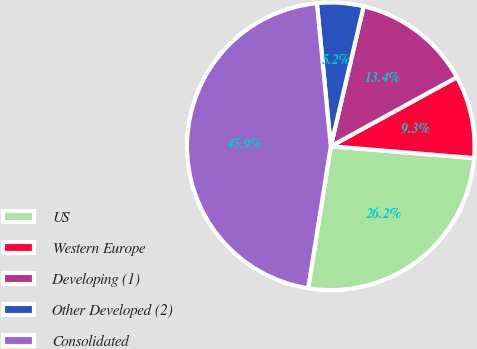Convert chart to OTSL. <chart><loc_0><loc_0><loc_500><loc_500><pie_chart><fcel>US<fcel>Western Europe<fcel>Developing (1)<fcel>Other Developed (2)<fcel>Consolidated<nl><fcel>26.21%<fcel>9.28%<fcel>13.35%<fcel>5.21%<fcel>45.94%<nl></chart> 